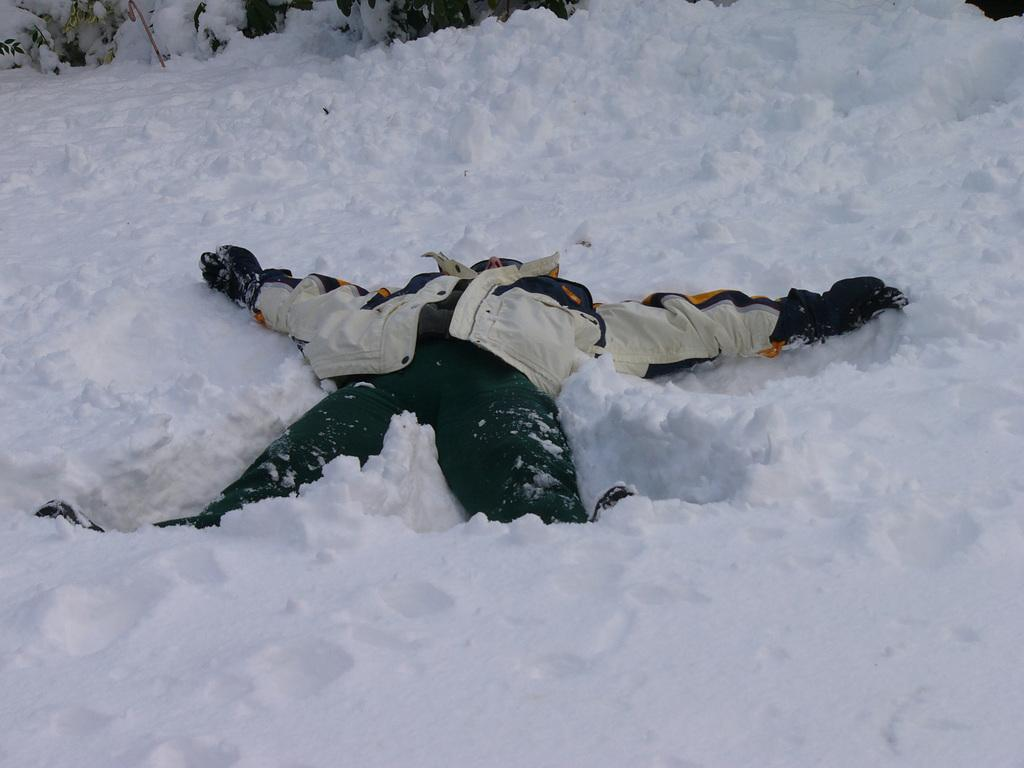What is the person in the image doing? The person is lying on the snow in the image. What is the person wearing? The person is wearing a different costume. What type of natural environment is visible in the image? There is snow visible in the background of the image. What else can be seen in the background of the image? There are objects present in the background of the image. What type of lettuce can be seen growing in the snow in the image? There is no lettuce present in the image; it features a person lying on the snow while wearing a different costume. 